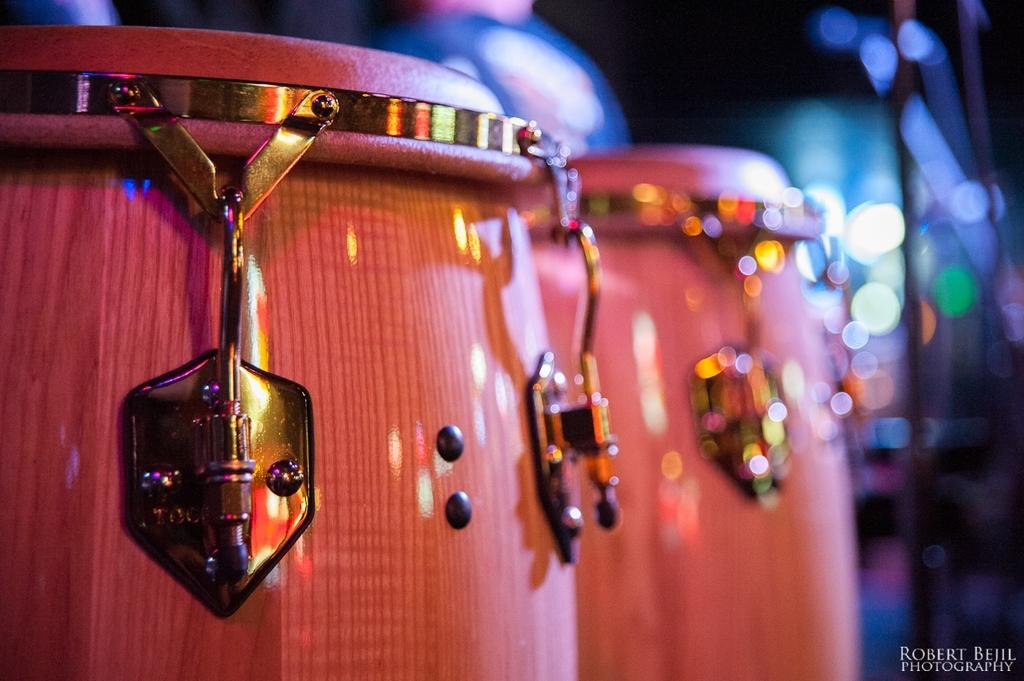What color can be observed in the objects present in the image? The objects in the image are pink in color. Can you describe the background of the image? The background of the image is blurry. How does the error in the image affect the memory of the objects? There is no error present in the image, and therefore it does not affect the memory of the objects. Can you tell me the number of kittens visible in the image? There are no kittens present in the image. 